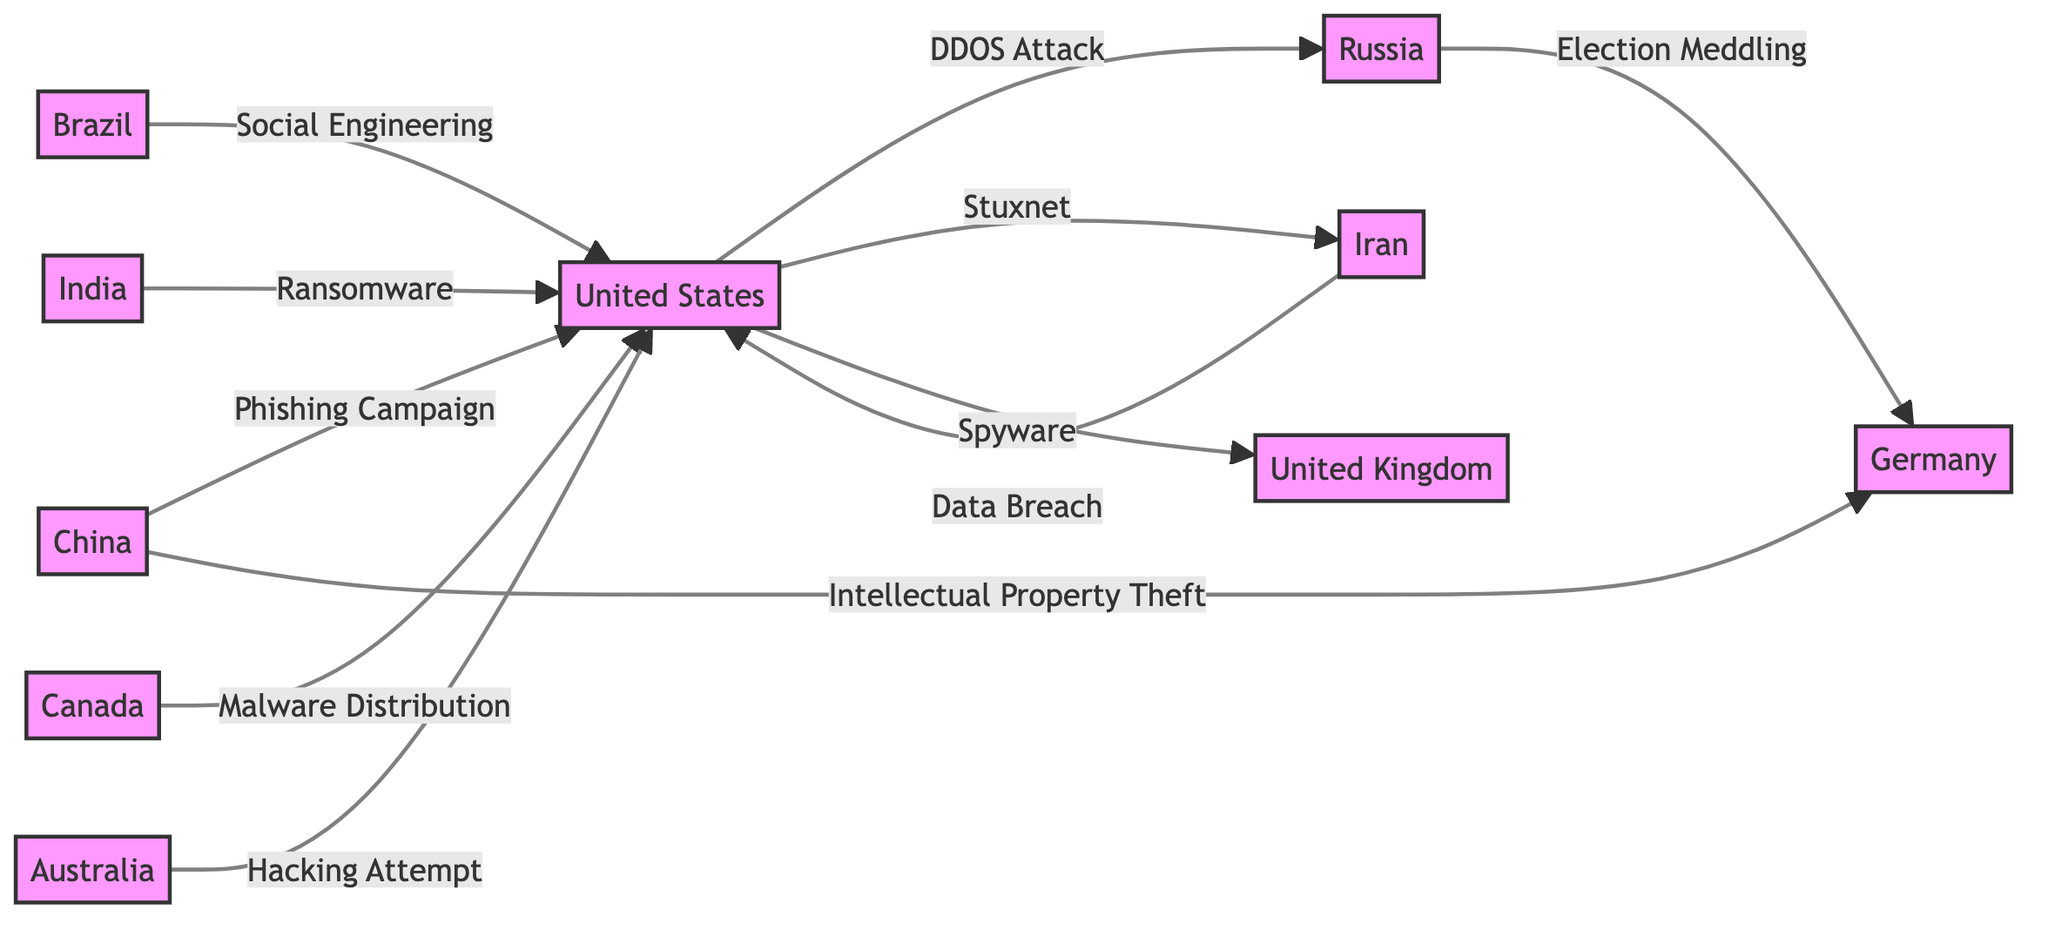What country is targeted by the most cyber attacks in this diagram? By examining the outgoing arrows from various countries, the United States has multiple incoming attacks: DDoS from Russia, Phishing from China, Data Breach from Iran, Social Engineering and Ransomware from Brazil and India respectively, Malware Distribution from Canada, and Hacking Attempt from Australia, making it the primary target.
Answer: United States Which country originated the DDoS attack? The diagram shows an arrow labeled "DDoS Attack" originating from the United States and pointing towards Russia, indicating that the United States is the source of the DDoS attack.
Answer: United States How many countries are represented as origins of cyber attacks in the diagram? By counting the nodes that have outgoing arrows, we find that the countries that initiate attacks are the USA, China, Iran, and Brazil, totaling four distinct origin countries.
Answer: 4 Which attack is directed from Iran towards the USA? The diagram indicates that there is a "Data Breach" attack that originates from Iran and is directed towards the United States, showing a clear connection.
Answer: Data Breach From which country does the intellectual property theft originate? The arrow labeled "Intellectual Property Theft" points from China to Germany, indicating that China is the source of this particular cyber attack.
Answer: China What is the total number of cyber attack types shown in the diagram? By listing the different types of attacks indicated on the arrows: DDoS Attack, Phishing Campaign, Data Breach, Election Meddling, Stuxnet, Social Engineering, Ransomware, Intellectual Property Theft, Spyware, Malware Distribution, and Hacking Attempt, we find there are 11 distinct types presented.
Answer: 11 Which two countries have a direct relationship through election meddling? The diagram shows an arrow labeled "Election Meddling" that connects Russia to Germany, indicating this specific relationship.
Answer: Russia and Germany What type of cyber attack is associated with Canada? The diagram shows that Canada is linked with the "Malware Distribution" attack directed toward the United States, defining the type of cyber attack involved.
Answer: Malware Distribution 